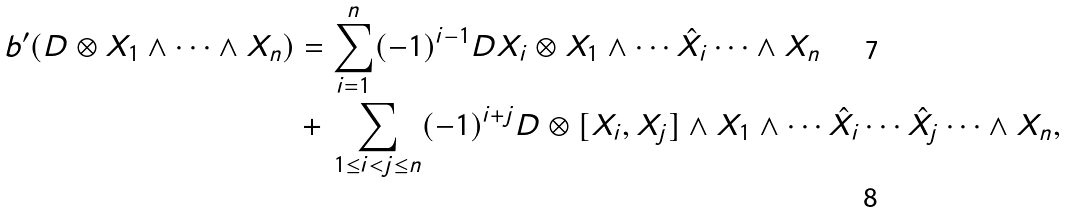Convert formula to latex. <formula><loc_0><loc_0><loc_500><loc_500>b ^ { \prime } ( D \otimes X _ { 1 } \wedge \cdots \wedge X _ { n } ) & = \sum ^ { n } _ { i = 1 } ( - 1 ) ^ { i - 1 } D X _ { i } \otimes X _ { 1 } \wedge \cdots \hat { X _ { i } } \cdots \wedge X _ { n } \\ & + \, \sum _ { 1 \leq i < j \leq n } ( - 1 ) ^ { i + j } D \otimes [ X _ { i } , X _ { j } ] \wedge X _ { 1 } \wedge \cdots \hat { X _ { i } } \cdots \hat { X _ { j } } \cdots \wedge X _ { n } ,</formula> 